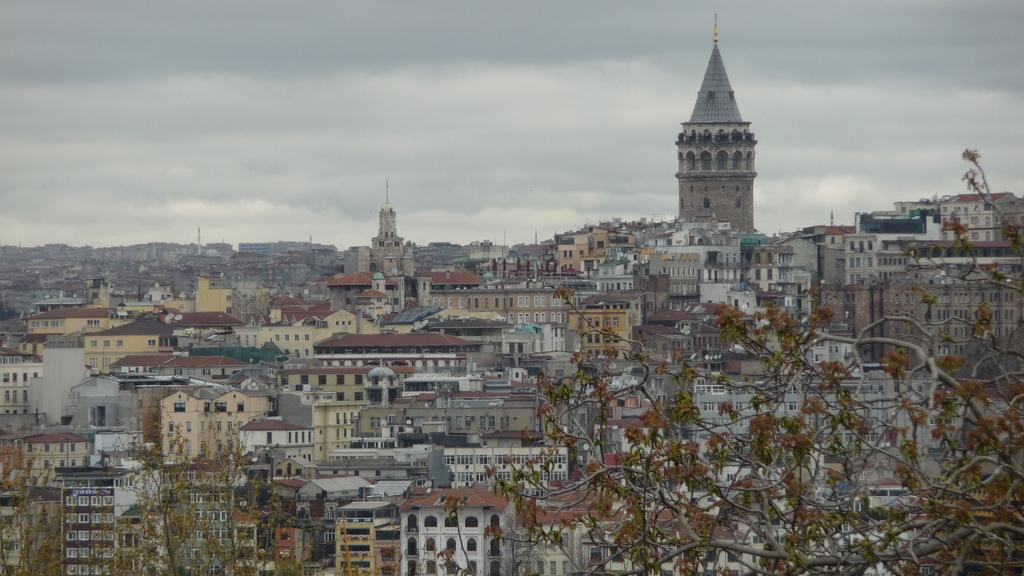What can be seen in the foreground of the image? There are trees and buildings in the foreground of the image. What else is present in the foreground besides the trees? There are also buildings in the foreground of the image. What is visible in the middle of the image? There are buildings in the middle of the image. What can be seen at the top of the image? The sky is visible at the top of the image. How many snails can be seen climbing the trees in the image? There are no snails present in the image; it features trees and buildings. What type of mice are visible in the buildings in the image? There are no mice present in the image; it only shows trees, buildings, and the sky. 